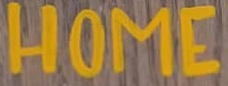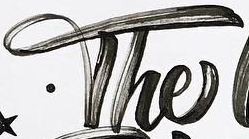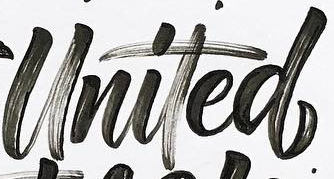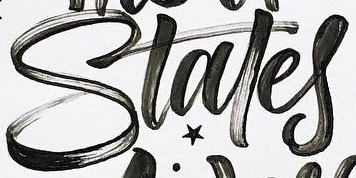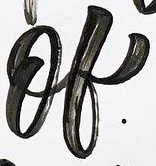What words can you see in these images in sequence, separated by a semicolon? HOME; The; United; Stales; of 